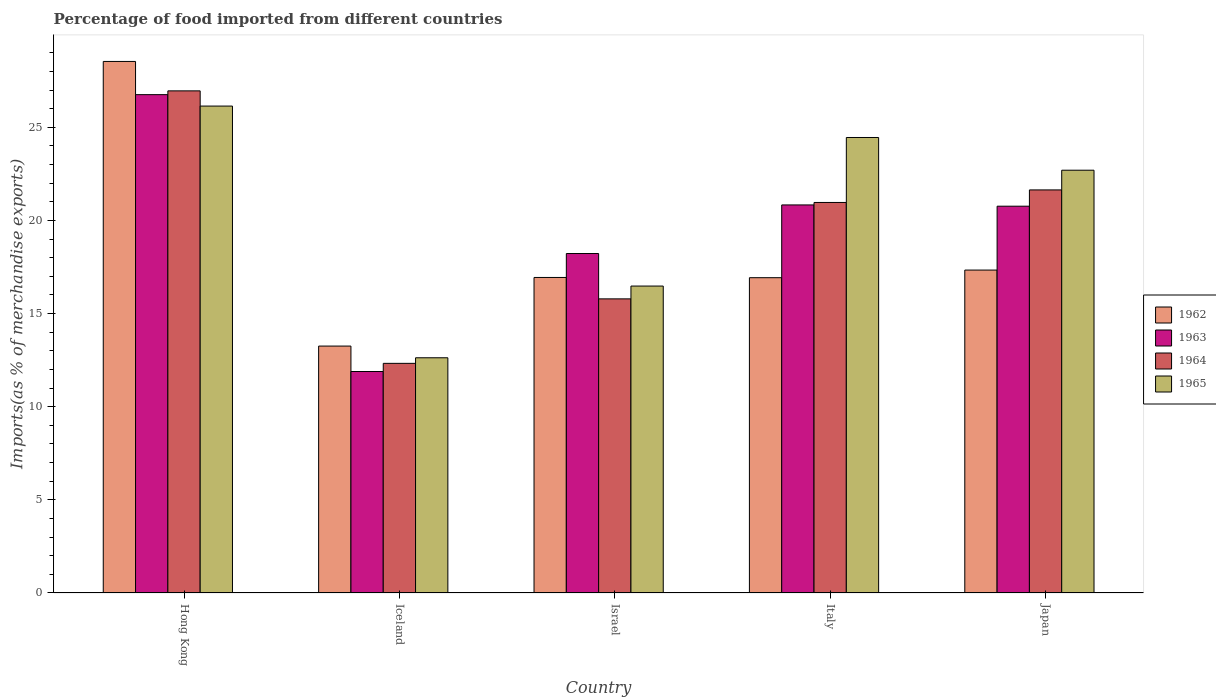Are the number of bars on each tick of the X-axis equal?
Offer a very short reply. Yes. How many bars are there on the 5th tick from the left?
Make the answer very short. 4. What is the label of the 4th group of bars from the left?
Make the answer very short. Italy. In how many cases, is the number of bars for a given country not equal to the number of legend labels?
Your answer should be very brief. 0. What is the percentage of imports to different countries in 1964 in Israel?
Keep it short and to the point. 15.79. Across all countries, what is the maximum percentage of imports to different countries in 1965?
Ensure brevity in your answer.  26.14. Across all countries, what is the minimum percentage of imports to different countries in 1963?
Your response must be concise. 11.89. In which country was the percentage of imports to different countries in 1963 maximum?
Keep it short and to the point. Hong Kong. What is the total percentage of imports to different countries in 1963 in the graph?
Provide a succinct answer. 98.46. What is the difference between the percentage of imports to different countries in 1965 in Hong Kong and that in Japan?
Your answer should be compact. 3.44. What is the difference between the percentage of imports to different countries in 1965 in Iceland and the percentage of imports to different countries in 1962 in Japan?
Offer a very short reply. -4.71. What is the average percentage of imports to different countries in 1964 per country?
Keep it short and to the point. 19.54. What is the difference between the percentage of imports to different countries of/in 1965 and percentage of imports to different countries of/in 1962 in Iceland?
Provide a short and direct response. -0.63. What is the ratio of the percentage of imports to different countries in 1965 in Israel to that in Italy?
Your answer should be compact. 0.67. Is the percentage of imports to different countries in 1965 in Hong Kong less than that in Japan?
Your answer should be compact. No. What is the difference between the highest and the second highest percentage of imports to different countries in 1965?
Give a very brief answer. -1.69. What is the difference between the highest and the lowest percentage of imports to different countries in 1962?
Your answer should be compact. 15.28. Is the sum of the percentage of imports to different countries in 1965 in Israel and Japan greater than the maximum percentage of imports to different countries in 1962 across all countries?
Keep it short and to the point. Yes. Is it the case that in every country, the sum of the percentage of imports to different countries in 1962 and percentage of imports to different countries in 1965 is greater than the sum of percentage of imports to different countries in 1963 and percentage of imports to different countries in 1964?
Make the answer very short. No. What does the 4th bar from the left in Israel represents?
Offer a terse response. 1965. What does the 2nd bar from the right in Japan represents?
Keep it short and to the point. 1964. How many bars are there?
Provide a short and direct response. 20. Are all the bars in the graph horizontal?
Your answer should be very brief. No. How many countries are there in the graph?
Your answer should be compact. 5. What is the difference between two consecutive major ticks on the Y-axis?
Provide a short and direct response. 5. Does the graph contain any zero values?
Your answer should be very brief. No. Does the graph contain grids?
Ensure brevity in your answer.  No. How many legend labels are there?
Provide a succinct answer. 4. What is the title of the graph?
Offer a terse response. Percentage of food imported from different countries. Does "1997" appear as one of the legend labels in the graph?
Your response must be concise. No. What is the label or title of the X-axis?
Your response must be concise. Country. What is the label or title of the Y-axis?
Offer a terse response. Imports(as % of merchandise exports). What is the Imports(as % of merchandise exports) of 1962 in Hong Kong?
Provide a short and direct response. 28.53. What is the Imports(as % of merchandise exports) of 1963 in Hong Kong?
Your answer should be compact. 26.75. What is the Imports(as % of merchandise exports) in 1964 in Hong Kong?
Give a very brief answer. 26.96. What is the Imports(as % of merchandise exports) in 1965 in Hong Kong?
Offer a terse response. 26.14. What is the Imports(as % of merchandise exports) in 1962 in Iceland?
Your answer should be very brief. 13.26. What is the Imports(as % of merchandise exports) of 1963 in Iceland?
Your response must be concise. 11.89. What is the Imports(as % of merchandise exports) in 1964 in Iceland?
Your answer should be very brief. 12.33. What is the Imports(as % of merchandise exports) in 1965 in Iceland?
Your response must be concise. 12.63. What is the Imports(as % of merchandise exports) of 1962 in Israel?
Keep it short and to the point. 16.94. What is the Imports(as % of merchandise exports) in 1963 in Israel?
Ensure brevity in your answer.  18.22. What is the Imports(as % of merchandise exports) in 1964 in Israel?
Your response must be concise. 15.79. What is the Imports(as % of merchandise exports) of 1965 in Israel?
Your response must be concise. 16.48. What is the Imports(as % of merchandise exports) of 1962 in Italy?
Your response must be concise. 16.93. What is the Imports(as % of merchandise exports) in 1963 in Italy?
Ensure brevity in your answer.  20.83. What is the Imports(as % of merchandise exports) of 1964 in Italy?
Ensure brevity in your answer.  20.97. What is the Imports(as % of merchandise exports) in 1965 in Italy?
Ensure brevity in your answer.  24.45. What is the Imports(as % of merchandise exports) in 1962 in Japan?
Your response must be concise. 17.34. What is the Imports(as % of merchandise exports) of 1963 in Japan?
Ensure brevity in your answer.  20.76. What is the Imports(as % of merchandise exports) of 1964 in Japan?
Provide a succinct answer. 21.64. What is the Imports(as % of merchandise exports) in 1965 in Japan?
Offer a very short reply. 22.7. Across all countries, what is the maximum Imports(as % of merchandise exports) in 1962?
Your answer should be compact. 28.53. Across all countries, what is the maximum Imports(as % of merchandise exports) of 1963?
Make the answer very short. 26.75. Across all countries, what is the maximum Imports(as % of merchandise exports) in 1964?
Your answer should be very brief. 26.96. Across all countries, what is the maximum Imports(as % of merchandise exports) in 1965?
Provide a short and direct response. 26.14. Across all countries, what is the minimum Imports(as % of merchandise exports) of 1962?
Give a very brief answer. 13.26. Across all countries, what is the minimum Imports(as % of merchandise exports) of 1963?
Keep it short and to the point. 11.89. Across all countries, what is the minimum Imports(as % of merchandise exports) in 1964?
Your response must be concise. 12.33. Across all countries, what is the minimum Imports(as % of merchandise exports) in 1965?
Your answer should be very brief. 12.63. What is the total Imports(as % of merchandise exports) of 1962 in the graph?
Your answer should be very brief. 92.99. What is the total Imports(as % of merchandise exports) in 1963 in the graph?
Offer a terse response. 98.46. What is the total Imports(as % of merchandise exports) of 1964 in the graph?
Offer a very short reply. 97.68. What is the total Imports(as % of merchandise exports) in 1965 in the graph?
Provide a short and direct response. 102.39. What is the difference between the Imports(as % of merchandise exports) in 1962 in Hong Kong and that in Iceland?
Ensure brevity in your answer.  15.28. What is the difference between the Imports(as % of merchandise exports) in 1963 in Hong Kong and that in Iceland?
Ensure brevity in your answer.  14.86. What is the difference between the Imports(as % of merchandise exports) of 1964 in Hong Kong and that in Iceland?
Ensure brevity in your answer.  14.63. What is the difference between the Imports(as % of merchandise exports) of 1965 in Hong Kong and that in Iceland?
Provide a short and direct response. 13.51. What is the difference between the Imports(as % of merchandise exports) of 1962 in Hong Kong and that in Israel?
Provide a succinct answer. 11.6. What is the difference between the Imports(as % of merchandise exports) of 1963 in Hong Kong and that in Israel?
Provide a succinct answer. 8.53. What is the difference between the Imports(as % of merchandise exports) of 1964 in Hong Kong and that in Israel?
Offer a very short reply. 11.17. What is the difference between the Imports(as % of merchandise exports) of 1965 in Hong Kong and that in Israel?
Offer a very short reply. 9.66. What is the difference between the Imports(as % of merchandise exports) in 1962 in Hong Kong and that in Italy?
Make the answer very short. 11.61. What is the difference between the Imports(as % of merchandise exports) in 1963 in Hong Kong and that in Italy?
Offer a terse response. 5.92. What is the difference between the Imports(as % of merchandise exports) in 1964 in Hong Kong and that in Italy?
Offer a very short reply. 5.99. What is the difference between the Imports(as % of merchandise exports) of 1965 in Hong Kong and that in Italy?
Keep it short and to the point. 1.69. What is the difference between the Imports(as % of merchandise exports) in 1962 in Hong Kong and that in Japan?
Provide a succinct answer. 11.2. What is the difference between the Imports(as % of merchandise exports) of 1963 in Hong Kong and that in Japan?
Ensure brevity in your answer.  5.99. What is the difference between the Imports(as % of merchandise exports) in 1964 in Hong Kong and that in Japan?
Provide a short and direct response. 5.32. What is the difference between the Imports(as % of merchandise exports) in 1965 in Hong Kong and that in Japan?
Provide a short and direct response. 3.44. What is the difference between the Imports(as % of merchandise exports) in 1962 in Iceland and that in Israel?
Provide a short and direct response. -3.68. What is the difference between the Imports(as % of merchandise exports) in 1963 in Iceland and that in Israel?
Make the answer very short. -6.33. What is the difference between the Imports(as % of merchandise exports) of 1964 in Iceland and that in Israel?
Provide a short and direct response. -3.46. What is the difference between the Imports(as % of merchandise exports) of 1965 in Iceland and that in Israel?
Make the answer very short. -3.85. What is the difference between the Imports(as % of merchandise exports) of 1962 in Iceland and that in Italy?
Make the answer very short. -3.67. What is the difference between the Imports(as % of merchandise exports) in 1963 in Iceland and that in Italy?
Offer a very short reply. -8.94. What is the difference between the Imports(as % of merchandise exports) in 1964 in Iceland and that in Italy?
Your response must be concise. -8.64. What is the difference between the Imports(as % of merchandise exports) of 1965 in Iceland and that in Italy?
Keep it short and to the point. -11.82. What is the difference between the Imports(as % of merchandise exports) in 1962 in Iceland and that in Japan?
Offer a very short reply. -4.08. What is the difference between the Imports(as % of merchandise exports) of 1963 in Iceland and that in Japan?
Ensure brevity in your answer.  -8.87. What is the difference between the Imports(as % of merchandise exports) in 1964 in Iceland and that in Japan?
Your answer should be compact. -9.31. What is the difference between the Imports(as % of merchandise exports) of 1965 in Iceland and that in Japan?
Offer a terse response. -10.07. What is the difference between the Imports(as % of merchandise exports) in 1962 in Israel and that in Italy?
Provide a succinct answer. 0.01. What is the difference between the Imports(as % of merchandise exports) in 1963 in Israel and that in Italy?
Make the answer very short. -2.61. What is the difference between the Imports(as % of merchandise exports) in 1964 in Israel and that in Italy?
Ensure brevity in your answer.  -5.18. What is the difference between the Imports(as % of merchandise exports) of 1965 in Israel and that in Italy?
Your answer should be compact. -7.97. What is the difference between the Imports(as % of merchandise exports) of 1962 in Israel and that in Japan?
Provide a short and direct response. -0.4. What is the difference between the Imports(as % of merchandise exports) in 1963 in Israel and that in Japan?
Keep it short and to the point. -2.54. What is the difference between the Imports(as % of merchandise exports) in 1964 in Israel and that in Japan?
Give a very brief answer. -5.85. What is the difference between the Imports(as % of merchandise exports) in 1965 in Israel and that in Japan?
Give a very brief answer. -6.22. What is the difference between the Imports(as % of merchandise exports) in 1962 in Italy and that in Japan?
Provide a short and direct response. -0.41. What is the difference between the Imports(as % of merchandise exports) of 1963 in Italy and that in Japan?
Offer a very short reply. 0.07. What is the difference between the Imports(as % of merchandise exports) of 1964 in Italy and that in Japan?
Make the answer very short. -0.67. What is the difference between the Imports(as % of merchandise exports) of 1965 in Italy and that in Japan?
Provide a short and direct response. 1.76. What is the difference between the Imports(as % of merchandise exports) in 1962 in Hong Kong and the Imports(as % of merchandise exports) in 1963 in Iceland?
Make the answer very short. 16.65. What is the difference between the Imports(as % of merchandise exports) of 1962 in Hong Kong and the Imports(as % of merchandise exports) of 1964 in Iceland?
Make the answer very short. 16.21. What is the difference between the Imports(as % of merchandise exports) of 1962 in Hong Kong and the Imports(as % of merchandise exports) of 1965 in Iceland?
Make the answer very short. 15.91. What is the difference between the Imports(as % of merchandise exports) of 1963 in Hong Kong and the Imports(as % of merchandise exports) of 1964 in Iceland?
Your answer should be compact. 14.43. What is the difference between the Imports(as % of merchandise exports) in 1963 in Hong Kong and the Imports(as % of merchandise exports) in 1965 in Iceland?
Make the answer very short. 14.13. What is the difference between the Imports(as % of merchandise exports) in 1964 in Hong Kong and the Imports(as % of merchandise exports) in 1965 in Iceland?
Ensure brevity in your answer.  14.33. What is the difference between the Imports(as % of merchandise exports) of 1962 in Hong Kong and the Imports(as % of merchandise exports) of 1963 in Israel?
Provide a succinct answer. 10.31. What is the difference between the Imports(as % of merchandise exports) in 1962 in Hong Kong and the Imports(as % of merchandise exports) in 1964 in Israel?
Offer a terse response. 12.75. What is the difference between the Imports(as % of merchandise exports) in 1962 in Hong Kong and the Imports(as % of merchandise exports) in 1965 in Israel?
Your answer should be compact. 12.06. What is the difference between the Imports(as % of merchandise exports) of 1963 in Hong Kong and the Imports(as % of merchandise exports) of 1964 in Israel?
Provide a short and direct response. 10.96. What is the difference between the Imports(as % of merchandise exports) in 1963 in Hong Kong and the Imports(as % of merchandise exports) in 1965 in Israel?
Offer a terse response. 10.28. What is the difference between the Imports(as % of merchandise exports) in 1964 in Hong Kong and the Imports(as % of merchandise exports) in 1965 in Israel?
Make the answer very short. 10.48. What is the difference between the Imports(as % of merchandise exports) in 1962 in Hong Kong and the Imports(as % of merchandise exports) in 1963 in Italy?
Offer a very short reply. 7.7. What is the difference between the Imports(as % of merchandise exports) of 1962 in Hong Kong and the Imports(as % of merchandise exports) of 1964 in Italy?
Make the answer very short. 7.57. What is the difference between the Imports(as % of merchandise exports) in 1962 in Hong Kong and the Imports(as % of merchandise exports) in 1965 in Italy?
Your response must be concise. 4.08. What is the difference between the Imports(as % of merchandise exports) in 1963 in Hong Kong and the Imports(as % of merchandise exports) in 1964 in Italy?
Your response must be concise. 5.79. What is the difference between the Imports(as % of merchandise exports) in 1963 in Hong Kong and the Imports(as % of merchandise exports) in 1965 in Italy?
Make the answer very short. 2.3. What is the difference between the Imports(as % of merchandise exports) in 1964 in Hong Kong and the Imports(as % of merchandise exports) in 1965 in Italy?
Provide a succinct answer. 2.5. What is the difference between the Imports(as % of merchandise exports) of 1962 in Hong Kong and the Imports(as % of merchandise exports) of 1963 in Japan?
Keep it short and to the point. 7.77. What is the difference between the Imports(as % of merchandise exports) of 1962 in Hong Kong and the Imports(as % of merchandise exports) of 1964 in Japan?
Provide a short and direct response. 6.9. What is the difference between the Imports(as % of merchandise exports) of 1962 in Hong Kong and the Imports(as % of merchandise exports) of 1965 in Japan?
Provide a succinct answer. 5.84. What is the difference between the Imports(as % of merchandise exports) of 1963 in Hong Kong and the Imports(as % of merchandise exports) of 1964 in Japan?
Provide a succinct answer. 5.11. What is the difference between the Imports(as % of merchandise exports) of 1963 in Hong Kong and the Imports(as % of merchandise exports) of 1965 in Japan?
Your answer should be compact. 4.06. What is the difference between the Imports(as % of merchandise exports) of 1964 in Hong Kong and the Imports(as % of merchandise exports) of 1965 in Japan?
Your response must be concise. 4.26. What is the difference between the Imports(as % of merchandise exports) of 1962 in Iceland and the Imports(as % of merchandise exports) of 1963 in Israel?
Keep it short and to the point. -4.97. What is the difference between the Imports(as % of merchandise exports) of 1962 in Iceland and the Imports(as % of merchandise exports) of 1964 in Israel?
Your answer should be very brief. -2.53. What is the difference between the Imports(as % of merchandise exports) of 1962 in Iceland and the Imports(as % of merchandise exports) of 1965 in Israel?
Provide a short and direct response. -3.22. What is the difference between the Imports(as % of merchandise exports) of 1963 in Iceland and the Imports(as % of merchandise exports) of 1964 in Israel?
Keep it short and to the point. -3.9. What is the difference between the Imports(as % of merchandise exports) of 1963 in Iceland and the Imports(as % of merchandise exports) of 1965 in Israel?
Offer a terse response. -4.59. What is the difference between the Imports(as % of merchandise exports) of 1964 in Iceland and the Imports(as % of merchandise exports) of 1965 in Israel?
Provide a short and direct response. -4.15. What is the difference between the Imports(as % of merchandise exports) in 1962 in Iceland and the Imports(as % of merchandise exports) in 1963 in Italy?
Your answer should be very brief. -7.58. What is the difference between the Imports(as % of merchandise exports) in 1962 in Iceland and the Imports(as % of merchandise exports) in 1964 in Italy?
Ensure brevity in your answer.  -7.71. What is the difference between the Imports(as % of merchandise exports) in 1962 in Iceland and the Imports(as % of merchandise exports) in 1965 in Italy?
Your response must be concise. -11.2. What is the difference between the Imports(as % of merchandise exports) of 1963 in Iceland and the Imports(as % of merchandise exports) of 1964 in Italy?
Make the answer very short. -9.08. What is the difference between the Imports(as % of merchandise exports) of 1963 in Iceland and the Imports(as % of merchandise exports) of 1965 in Italy?
Your response must be concise. -12.56. What is the difference between the Imports(as % of merchandise exports) of 1964 in Iceland and the Imports(as % of merchandise exports) of 1965 in Italy?
Your response must be concise. -12.13. What is the difference between the Imports(as % of merchandise exports) of 1962 in Iceland and the Imports(as % of merchandise exports) of 1963 in Japan?
Ensure brevity in your answer.  -7.51. What is the difference between the Imports(as % of merchandise exports) of 1962 in Iceland and the Imports(as % of merchandise exports) of 1964 in Japan?
Make the answer very short. -8.38. What is the difference between the Imports(as % of merchandise exports) of 1962 in Iceland and the Imports(as % of merchandise exports) of 1965 in Japan?
Your answer should be compact. -9.44. What is the difference between the Imports(as % of merchandise exports) of 1963 in Iceland and the Imports(as % of merchandise exports) of 1964 in Japan?
Provide a short and direct response. -9.75. What is the difference between the Imports(as % of merchandise exports) in 1963 in Iceland and the Imports(as % of merchandise exports) in 1965 in Japan?
Your answer should be very brief. -10.81. What is the difference between the Imports(as % of merchandise exports) of 1964 in Iceland and the Imports(as % of merchandise exports) of 1965 in Japan?
Keep it short and to the point. -10.37. What is the difference between the Imports(as % of merchandise exports) of 1962 in Israel and the Imports(as % of merchandise exports) of 1963 in Italy?
Give a very brief answer. -3.89. What is the difference between the Imports(as % of merchandise exports) in 1962 in Israel and the Imports(as % of merchandise exports) in 1964 in Italy?
Your answer should be very brief. -4.03. What is the difference between the Imports(as % of merchandise exports) in 1962 in Israel and the Imports(as % of merchandise exports) in 1965 in Italy?
Keep it short and to the point. -7.51. What is the difference between the Imports(as % of merchandise exports) in 1963 in Israel and the Imports(as % of merchandise exports) in 1964 in Italy?
Keep it short and to the point. -2.74. What is the difference between the Imports(as % of merchandise exports) in 1963 in Israel and the Imports(as % of merchandise exports) in 1965 in Italy?
Provide a short and direct response. -6.23. What is the difference between the Imports(as % of merchandise exports) in 1964 in Israel and the Imports(as % of merchandise exports) in 1965 in Italy?
Ensure brevity in your answer.  -8.66. What is the difference between the Imports(as % of merchandise exports) of 1962 in Israel and the Imports(as % of merchandise exports) of 1963 in Japan?
Make the answer very short. -3.83. What is the difference between the Imports(as % of merchandise exports) of 1962 in Israel and the Imports(as % of merchandise exports) of 1964 in Japan?
Provide a succinct answer. -4.7. What is the difference between the Imports(as % of merchandise exports) in 1962 in Israel and the Imports(as % of merchandise exports) in 1965 in Japan?
Provide a succinct answer. -5.76. What is the difference between the Imports(as % of merchandise exports) in 1963 in Israel and the Imports(as % of merchandise exports) in 1964 in Japan?
Offer a terse response. -3.41. What is the difference between the Imports(as % of merchandise exports) in 1963 in Israel and the Imports(as % of merchandise exports) in 1965 in Japan?
Provide a short and direct response. -4.47. What is the difference between the Imports(as % of merchandise exports) of 1964 in Israel and the Imports(as % of merchandise exports) of 1965 in Japan?
Your response must be concise. -6.91. What is the difference between the Imports(as % of merchandise exports) in 1962 in Italy and the Imports(as % of merchandise exports) in 1963 in Japan?
Your response must be concise. -3.84. What is the difference between the Imports(as % of merchandise exports) of 1962 in Italy and the Imports(as % of merchandise exports) of 1964 in Japan?
Make the answer very short. -4.71. What is the difference between the Imports(as % of merchandise exports) in 1962 in Italy and the Imports(as % of merchandise exports) in 1965 in Japan?
Offer a very short reply. -5.77. What is the difference between the Imports(as % of merchandise exports) of 1963 in Italy and the Imports(as % of merchandise exports) of 1964 in Japan?
Your response must be concise. -0.81. What is the difference between the Imports(as % of merchandise exports) in 1963 in Italy and the Imports(as % of merchandise exports) in 1965 in Japan?
Make the answer very short. -1.86. What is the difference between the Imports(as % of merchandise exports) in 1964 in Italy and the Imports(as % of merchandise exports) in 1965 in Japan?
Your answer should be very brief. -1.73. What is the average Imports(as % of merchandise exports) in 1962 per country?
Make the answer very short. 18.6. What is the average Imports(as % of merchandise exports) in 1963 per country?
Your response must be concise. 19.69. What is the average Imports(as % of merchandise exports) of 1964 per country?
Provide a succinct answer. 19.54. What is the average Imports(as % of merchandise exports) in 1965 per country?
Provide a succinct answer. 20.48. What is the difference between the Imports(as % of merchandise exports) in 1962 and Imports(as % of merchandise exports) in 1963 in Hong Kong?
Ensure brevity in your answer.  1.78. What is the difference between the Imports(as % of merchandise exports) in 1962 and Imports(as % of merchandise exports) in 1964 in Hong Kong?
Provide a short and direct response. 1.58. What is the difference between the Imports(as % of merchandise exports) in 1962 and Imports(as % of merchandise exports) in 1965 in Hong Kong?
Your response must be concise. 2.4. What is the difference between the Imports(as % of merchandise exports) of 1963 and Imports(as % of merchandise exports) of 1964 in Hong Kong?
Your answer should be very brief. -0.2. What is the difference between the Imports(as % of merchandise exports) of 1963 and Imports(as % of merchandise exports) of 1965 in Hong Kong?
Ensure brevity in your answer.  0.61. What is the difference between the Imports(as % of merchandise exports) in 1964 and Imports(as % of merchandise exports) in 1965 in Hong Kong?
Your response must be concise. 0.82. What is the difference between the Imports(as % of merchandise exports) of 1962 and Imports(as % of merchandise exports) of 1963 in Iceland?
Provide a succinct answer. 1.37. What is the difference between the Imports(as % of merchandise exports) in 1962 and Imports(as % of merchandise exports) in 1964 in Iceland?
Your answer should be compact. 0.93. What is the difference between the Imports(as % of merchandise exports) in 1962 and Imports(as % of merchandise exports) in 1965 in Iceland?
Offer a very short reply. 0.63. What is the difference between the Imports(as % of merchandise exports) in 1963 and Imports(as % of merchandise exports) in 1964 in Iceland?
Give a very brief answer. -0.44. What is the difference between the Imports(as % of merchandise exports) in 1963 and Imports(as % of merchandise exports) in 1965 in Iceland?
Offer a very short reply. -0.74. What is the difference between the Imports(as % of merchandise exports) of 1964 and Imports(as % of merchandise exports) of 1965 in Iceland?
Keep it short and to the point. -0.3. What is the difference between the Imports(as % of merchandise exports) of 1962 and Imports(as % of merchandise exports) of 1963 in Israel?
Your answer should be very brief. -1.29. What is the difference between the Imports(as % of merchandise exports) in 1962 and Imports(as % of merchandise exports) in 1964 in Israel?
Offer a terse response. 1.15. What is the difference between the Imports(as % of merchandise exports) in 1962 and Imports(as % of merchandise exports) in 1965 in Israel?
Ensure brevity in your answer.  0.46. What is the difference between the Imports(as % of merchandise exports) in 1963 and Imports(as % of merchandise exports) in 1964 in Israel?
Give a very brief answer. 2.43. What is the difference between the Imports(as % of merchandise exports) of 1963 and Imports(as % of merchandise exports) of 1965 in Israel?
Ensure brevity in your answer.  1.75. What is the difference between the Imports(as % of merchandise exports) of 1964 and Imports(as % of merchandise exports) of 1965 in Israel?
Offer a terse response. -0.69. What is the difference between the Imports(as % of merchandise exports) of 1962 and Imports(as % of merchandise exports) of 1963 in Italy?
Give a very brief answer. -3.91. What is the difference between the Imports(as % of merchandise exports) in 1962 and Imports(as % of merchandise exports) in 1964 in Italy?
Give a very brief answer. -4.04. What is the difference between the Imports(as % of merchandise exports) in 1962 and Imports(as % of merchandise exports) in 1965 in Italy?
Your response must be concise. -7.53. What is the difference between the Imports(as % of merchandise exports) of 1963 and Imports(as % of merchandise exports) of 1964 in Italy?
Offer a very short reply. -0.13. What is the difference between the Imports(as % of merchandise exports) of 1963 and Imports(as % of merchandise exports) of 1965 in Italy?
Give a very brief answer. -3.62. What is the difference between the Imports(as % of merchandise exports) in 1964 and Imports(as % of merchandise exports) in 1965 in Italy?
Keep it short and to the point. -3.49. What is the difference between the Imports(as % of merchandise exports) of 1962 and Imports(as % of merchandise exports) of 1963 in Japan?
Keep it short and to the point. -3.43. What is the difference between the Imports(as % of merchandise exports) of 1962 and Imports(as % of merchandise exports) of 1964 in Japan?
Offer a very short reply. -4.3. What is the difference between the Imports(as % of merchandise exports) in 1962 and Imports(as % of merchandise exports) in 1965 in Japan?
Ensure brevity in your answer.  -5.36. What is the difference between the Imports(as % of merchandise exports) in 1963 and Imports(as % of merchandise exports) in 1964 in Japan?
Offer a terse response. -0.87. What is the difference between the Imports(as % of merchandise exports) in 1963 and Imports(as % of merchandise exports) in 1965 in Japan?
Your answer should be compact. -1.93. What is the difference between the Imports(as % of merchandise exports) in 1964 and Imports(as % of merchandise exports) in 1965 in Japan?
Ensure brevity in your answer.  -1.06. What is the ratio of the Imports(as % of merchandise exports) in 1962 in Hong Kong to that in Iceland?
Give a very brief answer. 2.15. What is the ratio of the Imports(as % of merchandise exports) in 1963 in Hong Kong to that in Iceland?
Your answer should be very brief. 2.25. What is the ratio of the Imports(as % of merchandise exports) in 1964 in Hong Kong to that in Iceland?
Give a very brief answer. 2.19. What is the ratio of the Imports(as % of merchandise exports) of 1965 in Hong Kong to that in Iceland?
Offer a very short reply. 2.07. What is the ratio of the Imports(as % of merchandise exports) of 1962 in Hong Kong to that in Israel?
Offer a terse response. 1.68. What is the ratio of the Imports(as % of merchandise exports) in 1963 in Hong Kong to that in Israel?
Offer a very short reply. 1.47. What is the ratio of the Imports(as % of merchandise exports) of 1964 in Hong Kong to that in Israel?
Provide a short and direct response. 1.71. What is the ratio of the Imports(as % of merchandise exports) in 1965 in Hong Kong to that in Israel?
Offer a very short reply. 1.59. What is the ratio of the Imports(as % of merchandise exports) of 1962 in Hong Kong to that in Italy?
Your response must be concise. 1.69. What is the ratio of the Imports(as % of merchandise exports) in 1963 in Hong Kong to that in Italy?
Ensure brevity in your answer.  1.28. What is the ratio of the Imports(as % of merchandise exports) in 1964 in Hong Kong to that in Italy?
Your answer should be very brief. 1.29. What is the ratio of the Imports(as % of merchandise exports) of 1965 in Hong Kong to that in Italy?
Ensure brevity in your answer.  1.07. What is the ratio of the Imports(as % of merchandise exports) of 1962 in Hong Kong to that in Japan?
Give a very brief answer. 1.65. What is the ratio of the Imports(as % of merchandise exports) of 1963 in Hong Kong to that in Japan?
Keep it short and to the point. 1.29. What is the ratio of the Imports(as % of merchandise exports) of 1964 in Hong Kong to that in Japan?
Ensure brevity in your answer.  1.25. What is the ratio of the Imports(as % of merchandise exports) of 1965 in Hong Kong to that in Japan?
Ensure brevity in your answer.  1.15. What is the ratio of the Imports(as % of merchandise exports) in 1962 in Iceland to that in Israel?
Keep it short and to the point. 0.78. What is the ratio of the Imports(as % of merchandise exports) in 1963 in Iceland to that in Israel?
Your answer should be compact. 0.65. What is the ratio of the Imports(as % of merchandise exports) in 1964 in Iceland to that in Israel?
Ensure brevity in your answer.  0.78. What is the ratio of the Imports(as % of merchandise exports) in 1965 in Iceland to that in Israel?
Your answer should be compact. 0.77. What is the ratio of the Imports(as % of merchandise exports) in 1962 in Iceland to that in Italy?
Your answer should be very brief. 0.78. What is the ratio of the Imports(as % of merchandise exports) of 1963 in Iceland to that in Italy?
Give a very brief answer. 0.57. What is the ratio of the Imports(as % of merchandise exports) in 1964 in Iceland to that in Italy?
Your response must be concise. 0.59. What is the ratio of the Imports(as % of merchandise exports) of 1965 in Iceland to that in Italy?
Ensure brevity in your answer.  0.52. What is the ratio of the Imports(as % of merchandise exports) in 1962 in Iceland to that in Japan?
Make the answer very short. 0.76. What is the ratio of the Imports(as % of merchandise exports) of 1963 in Iceland to that in Japan?
Provide a succinct answer. 0.57. What is the ratio of the Imports(as % of merchandise exports) in 1964 in Iceland to that in Japan?
Your answer should be very brief. 0.57. What is the ratio of the Imports(as % of merchandise exports) of 1965 in Iceland to that in Japan?
Your response must be concise. 0.56. What is the ratio of the Imports(as % of merchandise exports) in 1962 in Israel to that in Italy?
Offer a terse response. 1. What is the ratio of the Imports(as % of merchandise exports) of 1963 in Israel to that in Italy?
Your answer should be very brief. 0.87. What is the ratio of the Imports(as % of merchandise exports) in 1964 in Israel to that in Italy?
Provide a short and direct response. 0.75. What is the ratio of the Imports(as % of merchandise exports) in 1965 in Israel to that in Italy?
Your response must be concise. 0.67. What is the ratio of the Imports(as % of merchandise exports) of 1962 in Israel to that in Japan?
Ensure brevity in your answer.  0.98. What is the ratio of the Imports(as % of merchandise exports) of 1963 in Israel to that in Japan?
Keep it short and to the point. 0.88. What is the ratio of the Imports(as % of merchandise exports) in 1964 in Israel to that in Japan?
Offer a terse response. 0.73. What is the ratio of the Imports(as % of merchandise exports) in 1965 in Israel to that in Japan?
Offer a very short reply. 0.73. What is the ratio of the Imports(as % of merchandise exports) in 1962 in Italy to that in Japan?
Ensure brevity in your answer.  0.98. What is the ratio of the Imports(as % of merchandise exports) of 1963 in Italy to that in Japan?
Offer a very short reply. 1. What is the ratio of the Imports(as % of merchandise exports) in 1964 in Italy to that in Japan?
Your answer should be very brief. 0.97. What is the ratio of the Imports(as % of merchandise exports) in 1965 in Italy to that in Japan?
Offer a terse response. 1.08. What is the difference between the highest and the second highest Imports(as % of merchandise exports) in 1962?
Offer a terse response. 11.2. What is the difference between the highest and the second highest Imports(as % of merchandise exports) in 1963?
Your answer should be very brief. 5.92. What is the difference between the highest and the second highest Imports(as % of merchandise exports) in 1964?
Ensure brevity in your answer.  5.32. What is the difference between the highest and the second highest Imports(as % of merchandise exports) of 1965?
Give a very brief answer. 1.69. What is the difference between the highest and the lowest Imports(as % of merchandise exports) in 1962?
Ensure brevity in your answer.  15.28. What is the difference between the highest and the lowest Imports(as % of merchandise exports) of 1963?
Your answer should be compact. 14.86. What is the difference between the highest and the lowest Imports(as % of merchandise exports) in 1964?
Ensure brevity in your answer.  14.63. What is the difference between the highest and the lowest Imports(as % of merchandise exports) in 1965?
Offer a terse response. 13.51. 